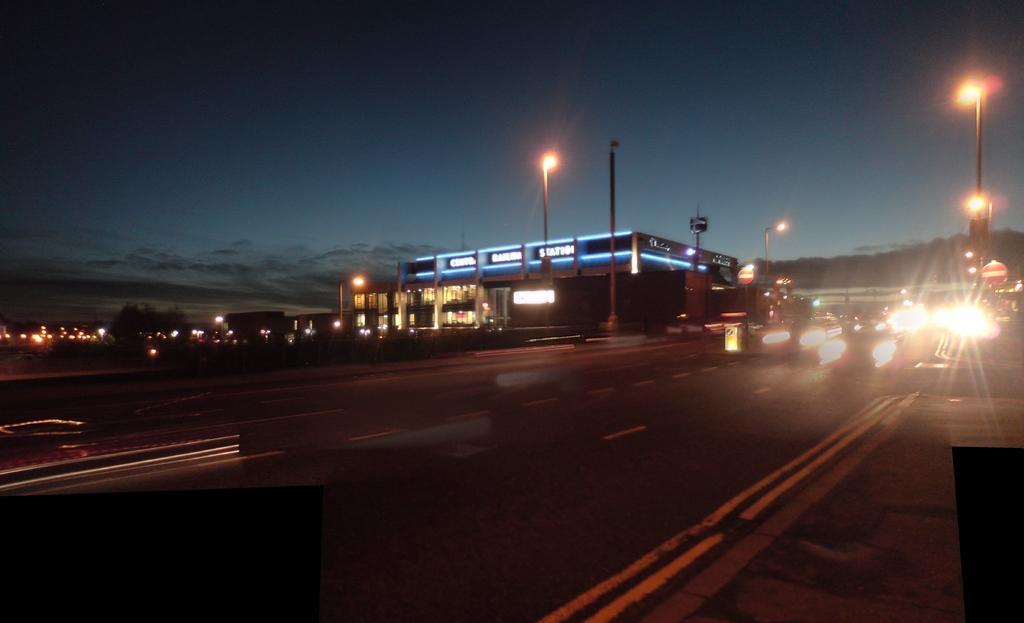How would you summarize this image in a sentence or two? This image is taken outdoors. At the top of the image there is a sky with clouds. At the bottom of the image there is a road and a few vehicles are moving on the road. In the middle of the image there is a building and many lights. On the right side of the image there is a street light and a signboard. 